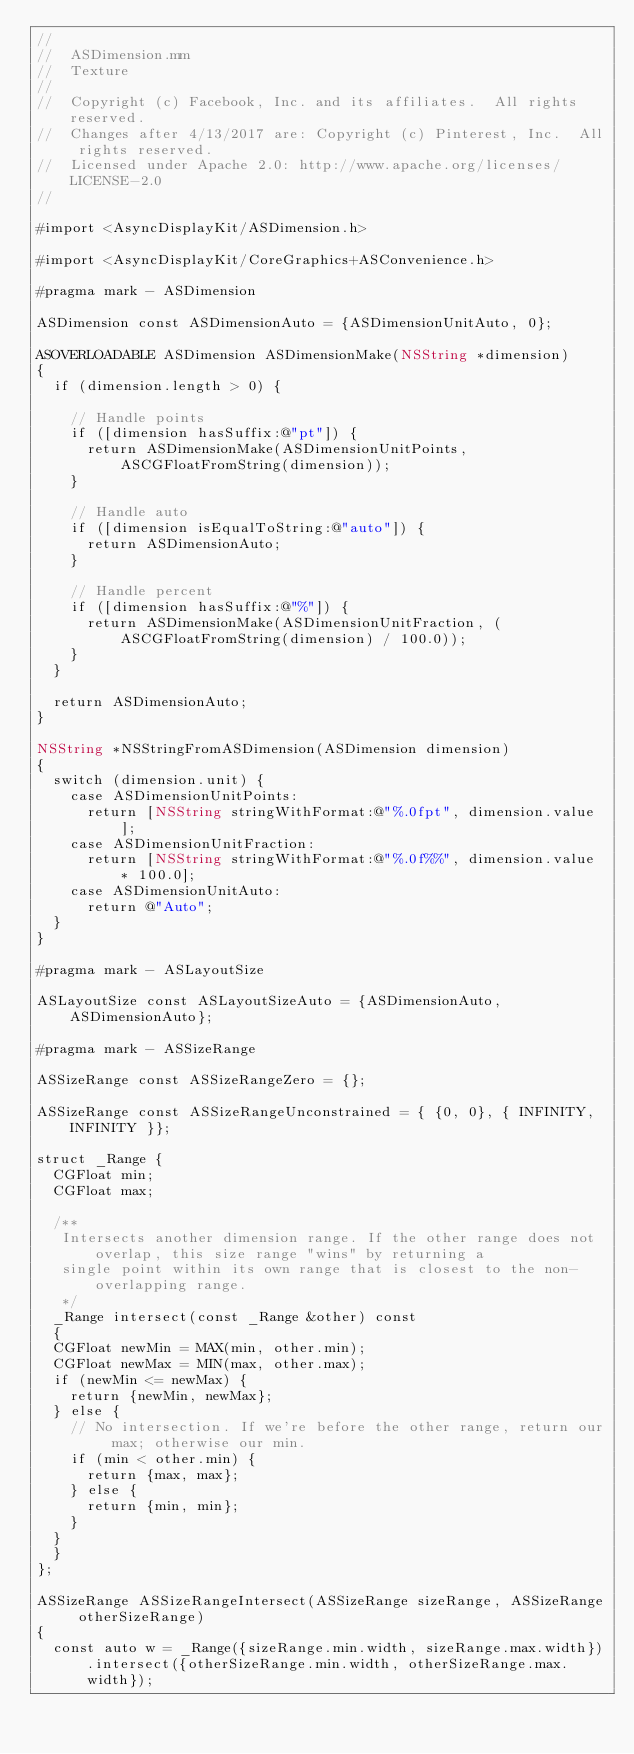<code> <loc_0><loc_0><loc_500><loc_500><_ObjectiveC_>//
//  ASDimension.mm
//  Texture
//
//  Copyright (c) Facebook, Inc. and its affiliates.  All rights reserved.
//  Changes after 4/13/2017 are: Copyright (c) Pinterest, Inc.  All rights reserved.
//  Licensed under Apache 2.0: http://www.apache.org/licenses/LICENSE-2.0
//

#import <AsyncDisplayKit/ASDimension.h>

#import <AsyncDisplayKit/CoreGraphics+ASConvenience.h>

#pragma mark - ASDimension

ASDimension const ASDimensionAuto = {ASDimensionUnitAuto, 0};

ASOVERLOADABLE ASDimension ASDimensionMake(NSString *dimension)
{
  if (dimension.length > 0) {
    
    // Handle points
    if ([dimension hasSuffix:@"pt"]) {
      return ASDimensionMake(ASDimensionUnitPoints, ASCGFloatFromString(dimension));
    }
    
    // Handle auto
    if ([dimension isEqualToString:@"auto"]) {
      return ASDimensionAuto;
    }
  
    // Handle percent
    if ([dimension hasSuffix:@"%"]) {
      return ASDimensionMake(ASDimensionUnitFraction, (ASCGFloatFromString(dimension) / 100.0));
    }
  }
  
  return ASDimensionAuto;
}

NSString *NSStringFromASDimension(ASDimension dimension)
{
  switch (dimension.unit) {
    case ASDimensionUnitPoints:
      return [NSString stringWithFormat:@"%.0fpt", dimension.value];
    case ASDimensionUnitFraction:
      return [NSString stringWithFormat:@"%.0f%%", dimension.value * 100.0];
    case ASDimensionUnitAuto:
      return @"Auto";
  }
}

#pragma mark - ASLayoutSize

ASLayoutSize const ASLayoutSizeAuto = {ASDimensionAuto, ASDimensionAuto};

#pragma mark - ASSizeRange

ASSizeRange const ASSizeRangeZero = {};

ASSizeRange const ASSizeRangeUnconstrained = { {0, 0}, { INFINITY, INFINITY }};

struct _Range {
  CGFloat min;
  CGFloat max;
  
  /**
   Intersects another dimension range. If the other range does not overlap, this size range "wins" by returning a
   single point within its own range that is closest to the non-overlapping range.
   */
  _Range intersect(const _Range &other) const
  {
  CGFloat newMin = MAX(min, other.min);
  CGFloat newMax = MIN(max, other.max);
  if (newMin <= newMax) {
    return {newMin, newMax};
  } else {
    // No intersection. If we're before the other range, return our max; otherwise our min.
    if (min < other.min) {
      return {max, max};
    } else {
      return {min, min};
    }
  }
  }
};

ASSizeRange ASSizeRangeIntersect(ASSizeRange sizeRange, ASSizeRange otherSizeRange)
{
  const auto w = _Range({sizeRange.min.width, sizeRange.max.width}).intersect({otherSizeRange.min.width, otherSizeRange.max.width});</code> 